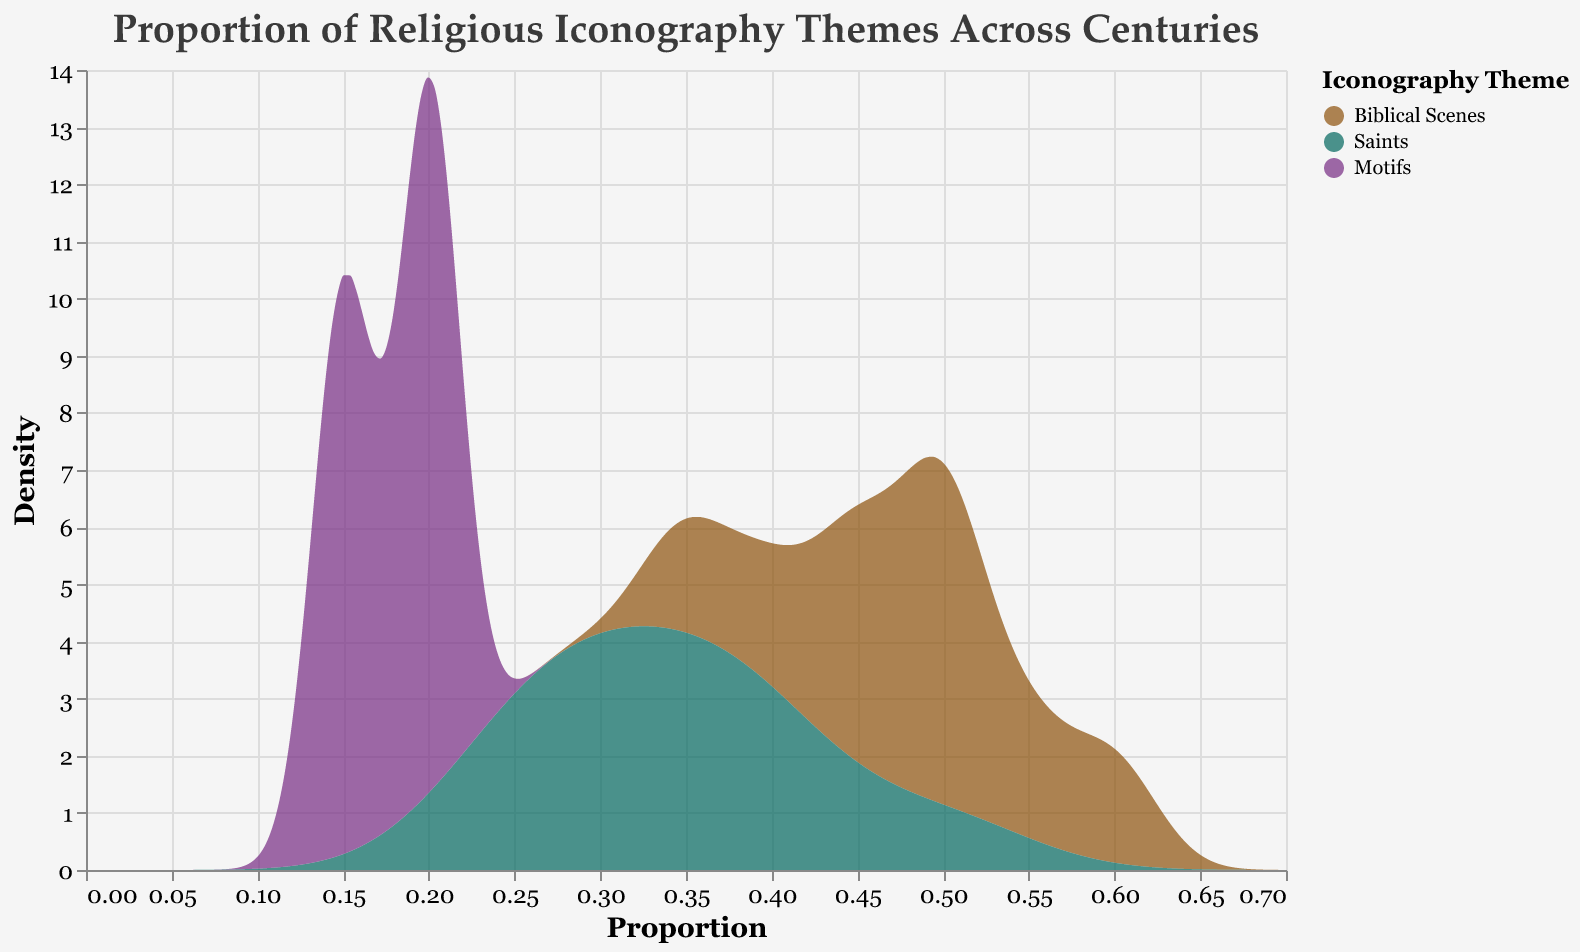What is the title of the figure? The title of the figure is usually located at the top and clearly displays the main subject of the plot. Here, the title states the purpose and context of the plot: "Proportion of Religious Iconography Themes Across Centuries"
Answer: Proportion of Religious Iconography Themes Across Centuries Which theme shows the highest peak in proportion density? To determine the highest peak in proportion density, look for the curve that reaches the highest value on the y-axis in the plot. The "Biblical Scenes" theme has the highest peak.
Answer: Biblical Scene What is the most common proportion range for Saints theme? For the most common proportion range, we look at where the density curve for the Saints theme is highest. The curve for Saints peaks around 0.25 to 0.50.
Answer: 0.25 to 0.50 Which theme shows the widest spread in proportions? A wider spread in proportions indicates a broader range on the x-axis. The "Biblical Scenes" theme spans from roughly 0.35 to 0.60, showing the widest spread among themes.
Answer: Biblical Scenes How does the density of the Motifs theme compare to the other themes at the 0.20 proportion mark? To compare densities at the 0.20 proportion mark, observe the y-values of the curves at this x-value. The Motifs theme has a high density compared to the other themes, which are lower at this mark.
Answer: Higher Which century shows a significant peak in the density for the theme of Saints? To identify significant peaks by century, observe where the density curve for Saints has its highest values. This occurs in the 20th century, where the proportion is highest at 0.50.
Answer: 20th century What is the general trend in the proportion of Biblical Scenes from century 16th to the 20th century? Observe the peaks corresponding to the centuries on the density plot for Biblical Scenes, noting any trends. From the 16th century to the 20th century, the proportion generally declines, first staying steady and then dropping.
Answer: Decline Comparing the proportions of themes in the 20th century, which theme has the highest density? Examining the density plots for the 20th century and identifying which theme reaches the highest value on the y-axis shows that Saints have the highest density.
Answer: Saints What can be inferred about the prevalence of motifs over the centuries? Observe the density plot for the Motifs theme, noting the consistent low value. This suggests that motifs remained consistently less prevalent compared to other themes.
Answer: Consistently less prevalent How do the proportions of Saints in the 18th century compare to the 13th century? Look at the density plots for Saints at these two centuries. In the 13th century, the proportion for Saints is around 0.40 whereas it peaks again to a similar proportion in the 18th century.
Answer: Similar 